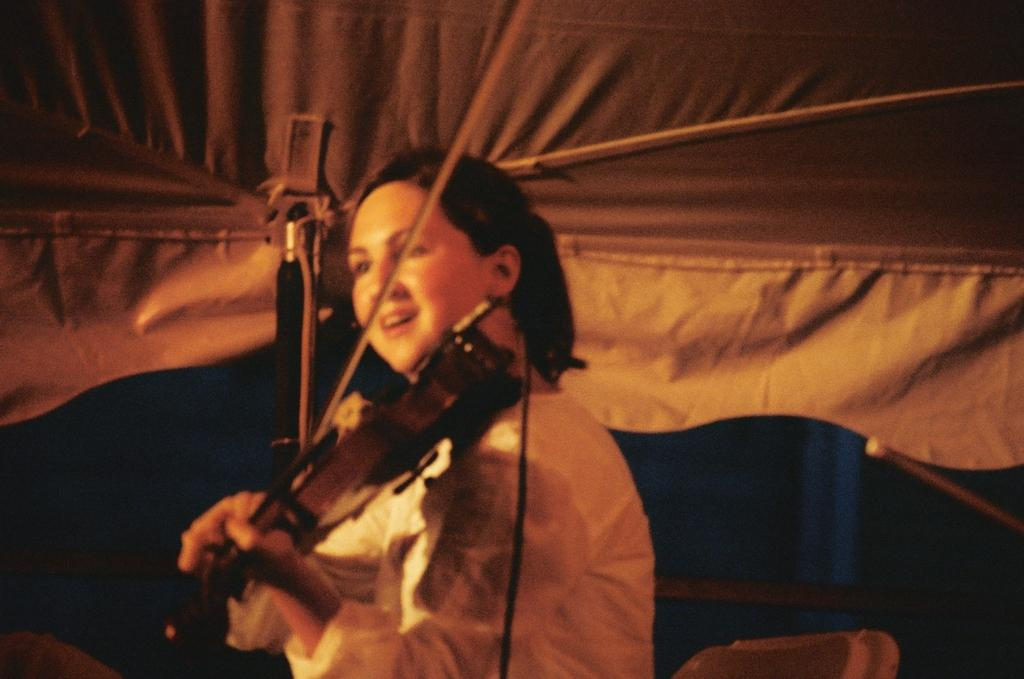What is the woman in the image doing? The woman is playing a violin in the image. Can you describe the cloth at the top of the image? The cloth may be part of a tent, and it is located at the top of the image. How would you describe the lighting in the image? The background of the image appears dark. What type of spade is being used to play the violin in the image? There is no spade present in the image; the woman is playing a violin with her hands. Can you see a club or any other sports equipment in the image? There is no club or sports equipment visible in the image. 